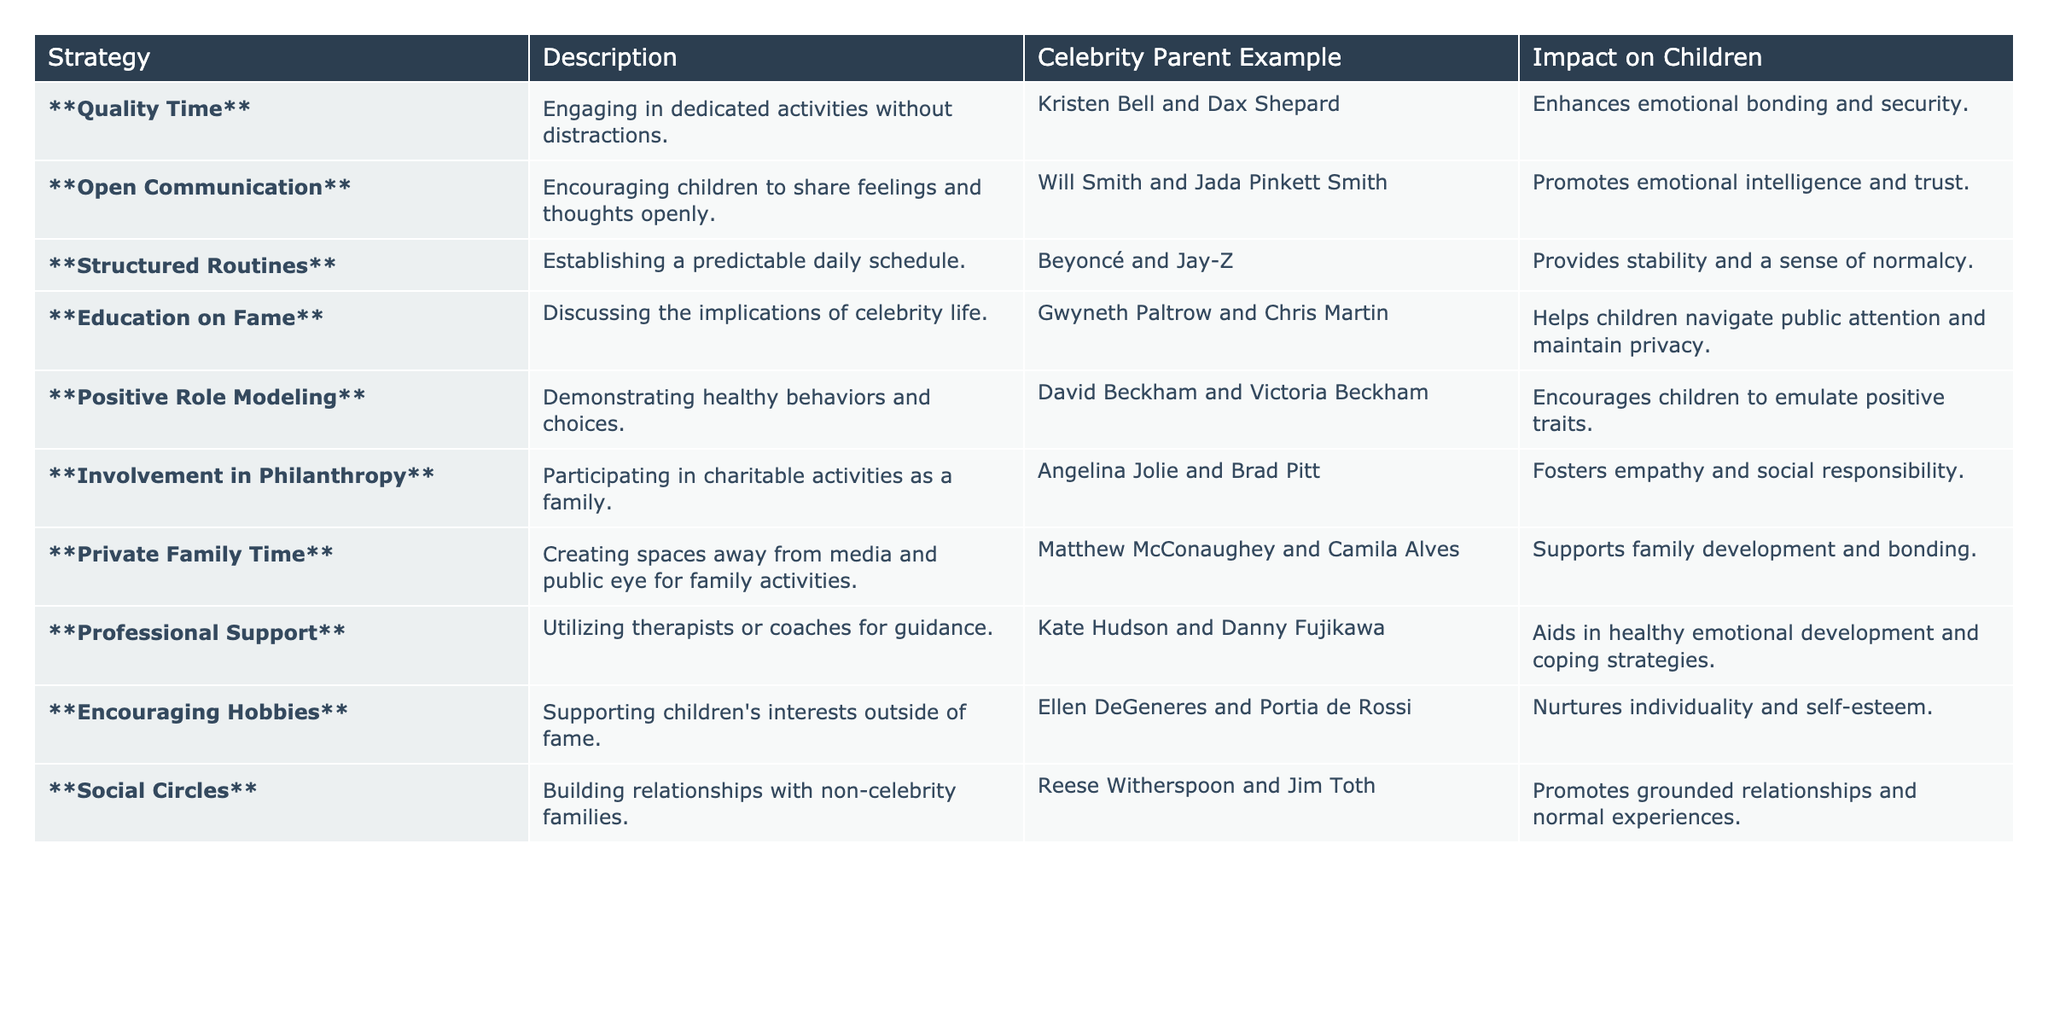What strategy involves creating family activities away from media? The table lists "Private Family Time" as a strategy which focuses on creating spaces for family activities away from the media.
Answer: Private Family Time Which celebrity parents emphasize the importance of open communication? The table identifies Will Smith and Jada Pinkett Smith as an example of celebrity parents who encourage open communication in their family.
Answer: Will Smith and Jada Pinkett Smith How many strategies mentioned involve philanthropy? The table shows one strategy related to philanthropy: "Involvement in Philanthropy," highlighting participating in charitable activities.
Answer: 1 Does the "Structured Routines" strategy positively impact children's sense of normalcy? The description under "Structured Routines" states that it provides stability and a sense of normalcy, indicating a positive impact.
Answer: Yes Which parental engagement strategy listed aims to enhance emotional intelligence? The strategy "Open Communication" is aimed at promoting emotional intelligence and trust, as seen in its impact description.
Answer: Open Communication What are the celebrity parent examples associated with positive role modeling? David Beckham and Victoria Beckham are cited in the table as examples of parents demonstrating positive role modeling through healthy behaviors.
Answer: David Beckham and Victoria Beckham How many strategies aim to encourage children's individuality? There are two strategies that aim to encourage individuality: "Encouraging Hobbies" and "Private Family Time," highlighting children’s interests and providing unmediated family moments.
Answer: 2 Which strategy emphasizes the importance of navigating public attention for children? The strategy "Education on Fame" discusses the implications of celebrity life and helps children navigate public attention.
Answer: Education on Fame Which impact statement corresponds to the strategy that encourages empathy? The "Involvement in Philanthropy" strategy mentions fostering empathy and social responsibility as its impact statement.
Answer: Fosters empathy and social responsibility What is the common theme among the strategies related to emotional support? Strategies like "Open Communication" and "Professional Support" revolve around enhancing emotional support for children, focusing on sharing feelings and utilizing therapists.
Answer: Emotional support 